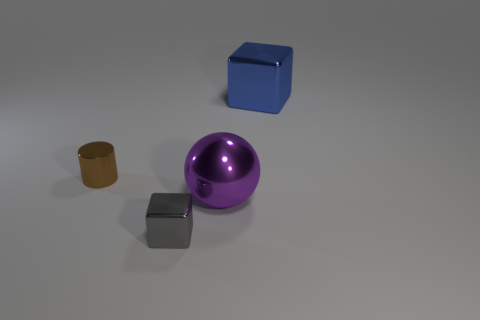There is a brown metal cylinder behind the small gray cube; what number of brown metallic things are behind it?
Your response must be concise. 0. Are there any tiny blue objects of the same shape as the purple shiny object?
Offer a terse response. No. There is a small metal object that is on the right side of the metallic object to the left of the tiny block; what is its color?
Your answer should be compact. Gray. Is the number of small gray blocks greater than the number of big brown objects?
Give a very brief answer. Yes. What number of blue matte cylinders have the same size as the gray shiny object?
Ensure brevity in your answer.  0. Does the large blue thing have the same material as the block that is in front of the large purple metal ball?
Ensure brevity in your answer.  Yes. Is the number of red rubber spheres less than the number of metal objects?
Your response must be concise. Yes. Is there any other thing of the same color as the sphere?
Give a very brief answer. No. The gray thing that is made of the same material as the tiny brown object is what shape?
Give a very brief answer. Cube. There is a small object that is in front of the small thing that is behind the large purple ball; how many blue objects are left of it?
Your response must be concise. 0. 